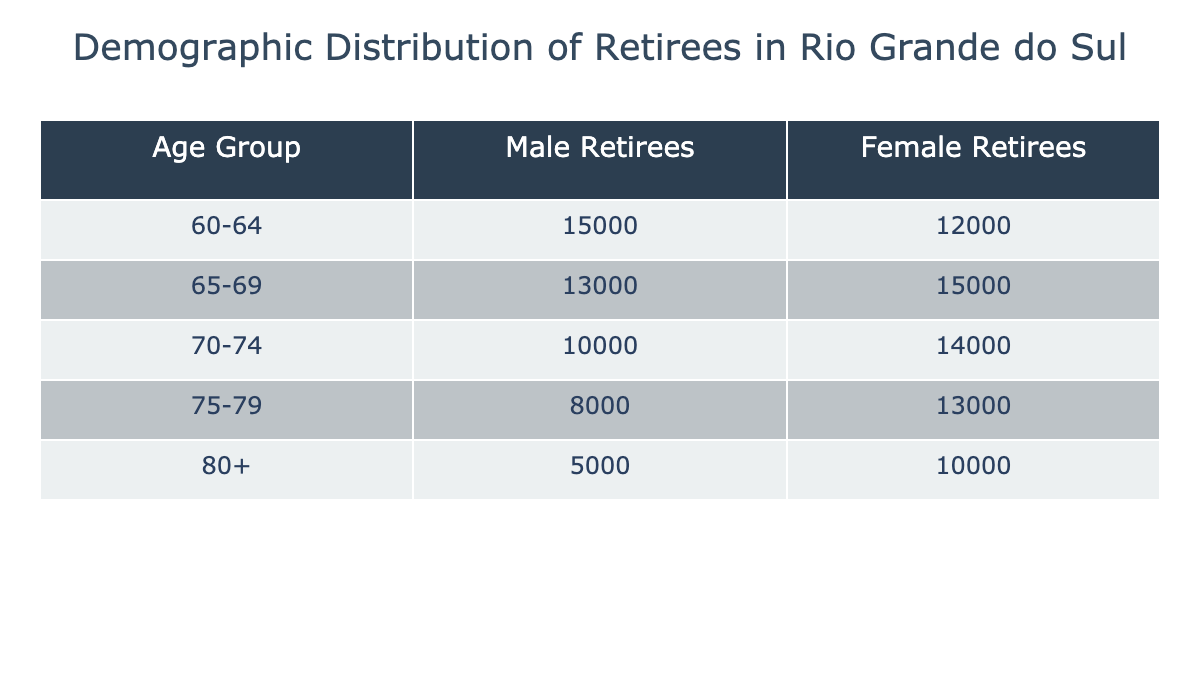What is the total number of male retirees aged 60-64? The table shows that the number of male retirees in the age group 60-64 is listed directly. So, we look at the “Male Retirees” column for that age group and see the value is 15000.
Answer: 15000 What is the number of female retirees aged 75-79? According to the table, the age group 75-79 has a corresponding value in the "Female Retirees" column. The value listed there is 13000.
Answer: 13000 Which age group has the highest number of male retirees? To determine this, we check the "Male Retirees" column for each age group. The maximum value is 15000 in the 60-64 age group, which is the highest among all groups.
Answer: 60-64 What is the percentage of female retirees aged 70-74 compared to male retirees in the same age group? First, we find the female retirees in the 70-74 age group, which is 14000. Then, we find the male retirees for that age group, which is 10000. The percentage is calculated as (14000 / 10000) * 100 = 140%.
Answer: 140% Is there a higher number of male or female retirees aged 80 and above? For the age group 80+, the number of male retirees is 5000, while the female retirees are 10000. Comparing these values shows that 10000 female retirees exceed 5000 male retirees.
Answer: Female retirees What is the total number of retirees (male and female) in the 65-69 age group? We find the number of male retirees (13000) and female retirees (15000) in the 65-69 age group. Adding these together gives us the total: 13000 + 15000 = 28000.
Answer: 28000 Is the number of male retirees in the 70-74 age group less than the number of female retirees in the 75-79 age group? The number of male retirees in the 70-74 age group is 10000, and for female retirees in the 75-79 age group, it is 13000. Since 10000 is less than 13000, the answer is yes.
Answer: Yes Which age group has the lowest total number of retirees combined? We calculate the total retirees for each age group by adding male and female numbers. The totals are: 27000 for 60-64, 28000 for 65-69, 24000 for 70-74, 21000 for 75-79, and 15000 for 80+. The lowest total is 15000 in the 80+ age group.
Answer: 80+ What is the average number of female retirees across all age groups? To find the average, we first total the female retirees: 12000 + 15000 + 14000 + 13000 + 10000 = 74000. There are 5 age groups, so we divide: 74000 / 5 = 14800.
Answer: 14800 